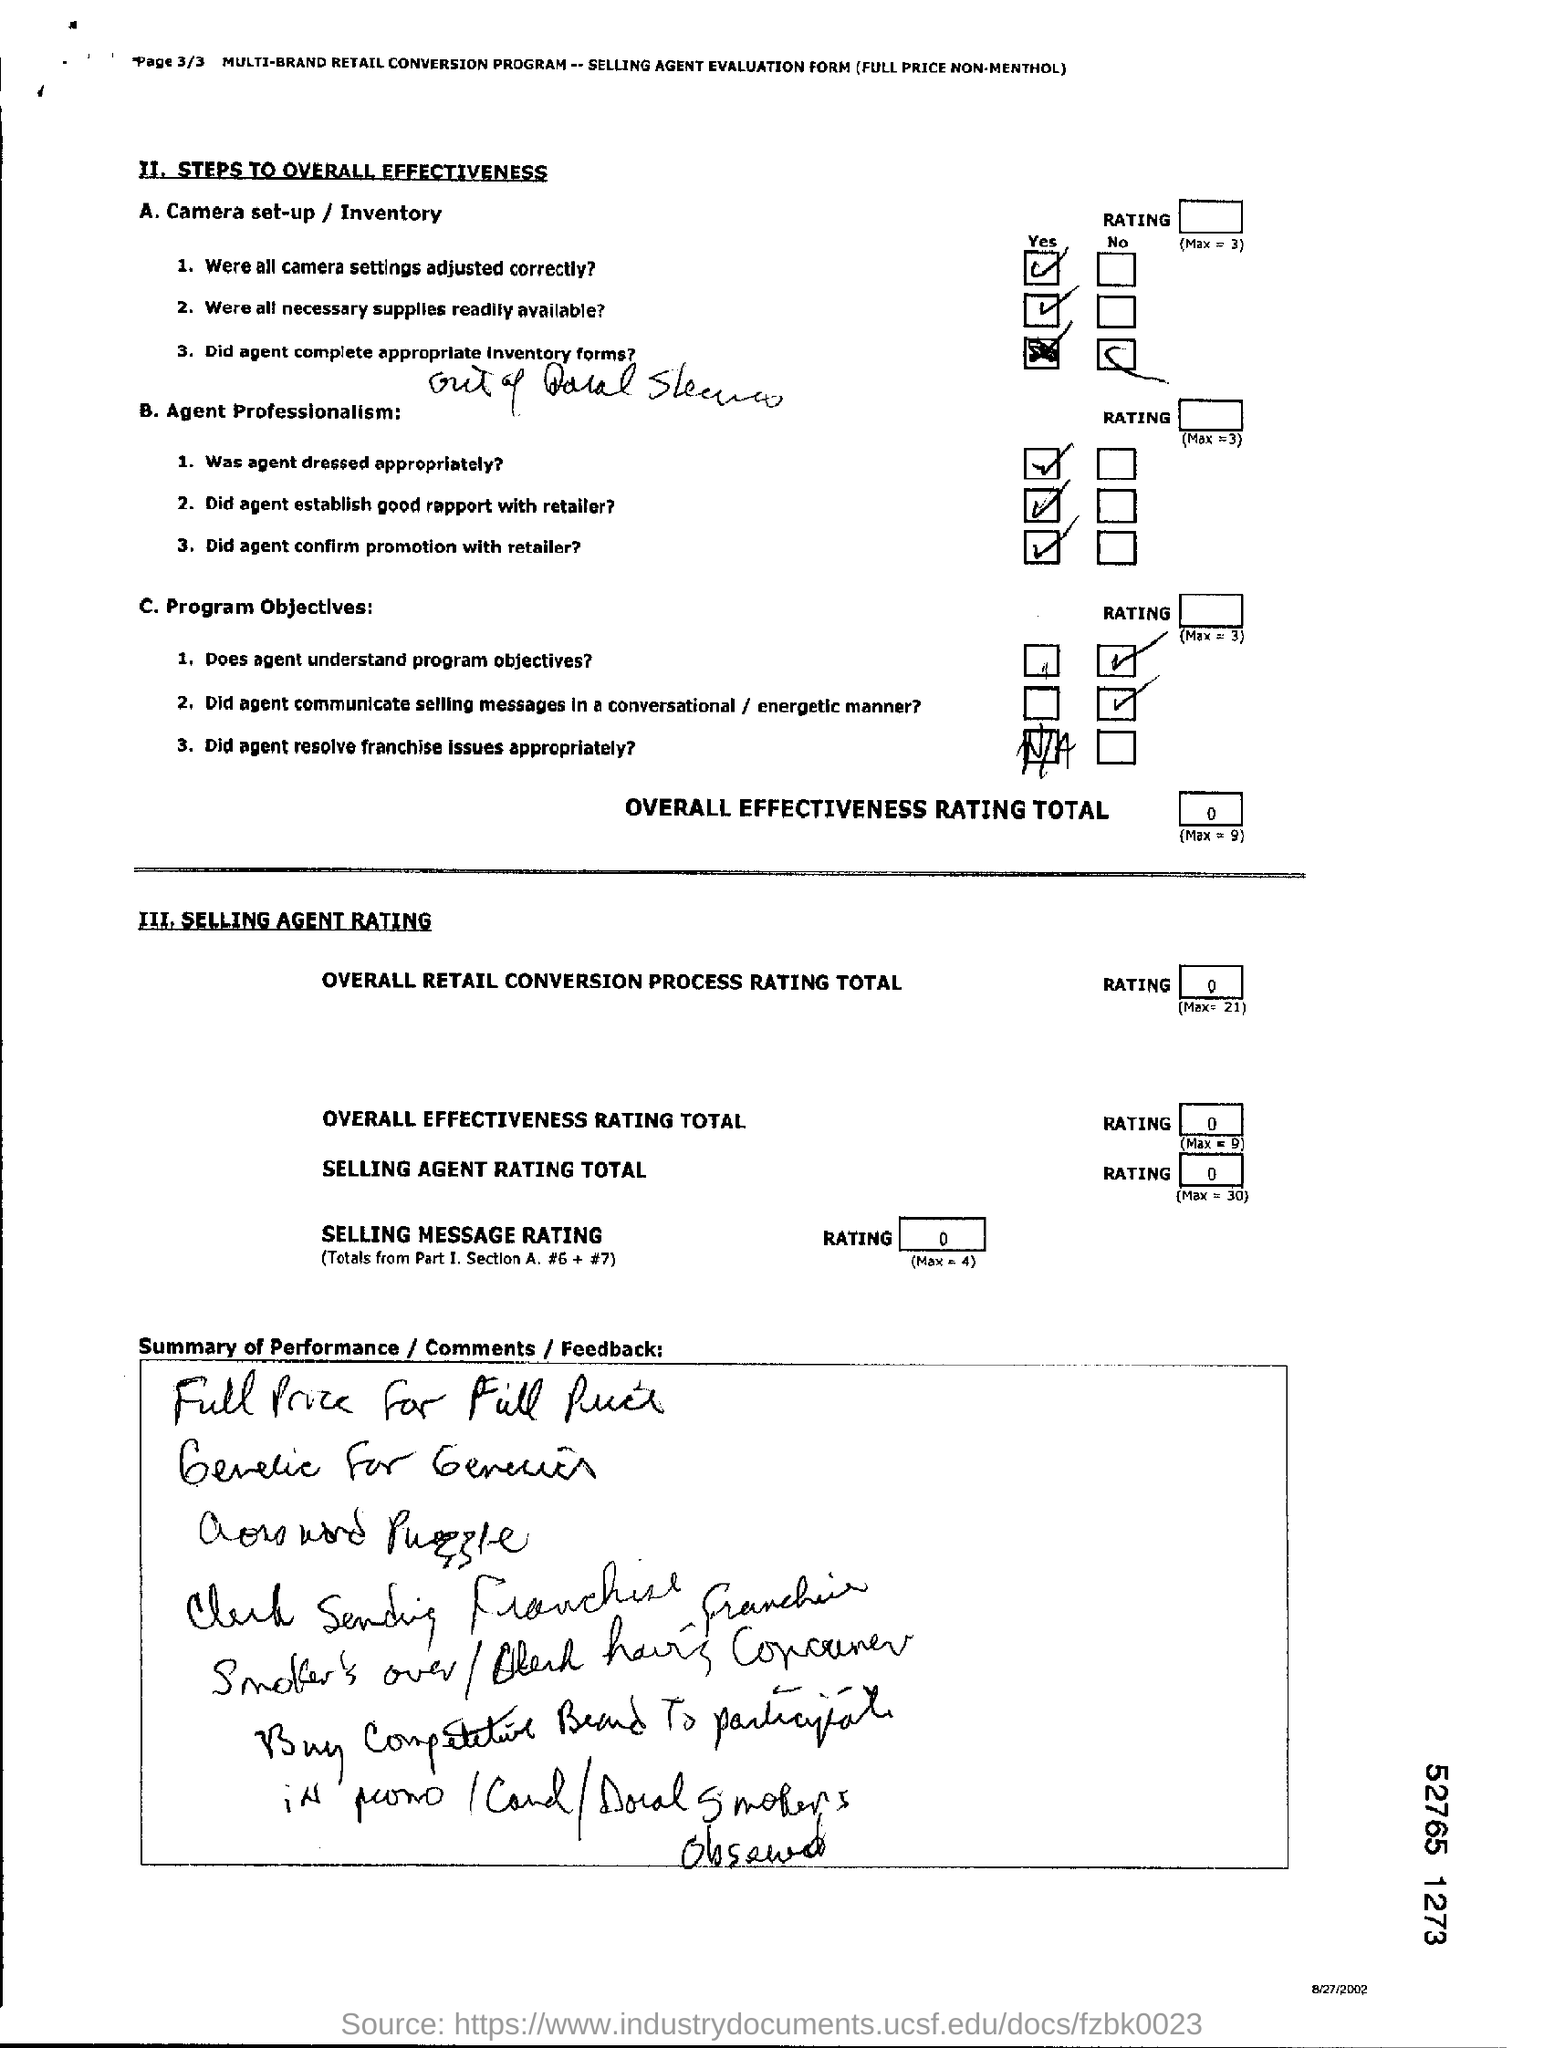Where all necessary suppliers readily available? Based on the image, which is an evaluation form, it appears that the necessary suppliers were readily available, as indicated by the checked 'Yes' box next to the relevant question regarding camera set-up and inventory. However, the image does not provide conclusive evidence about the availability of all types of suppliers beyond the context of a camera set-up for a retail conversion program. 